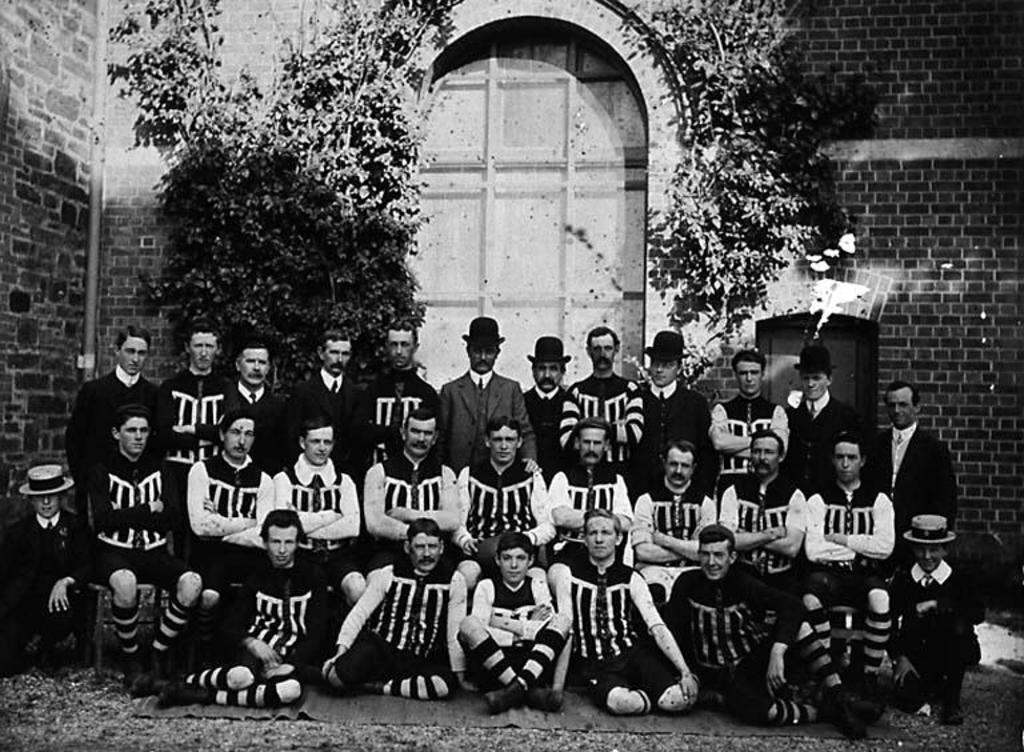What is the color scheme of the image? The image is black and white. Can you describe the people in the image? There are people in the image. What type of surface is visible in the image? There is ground visible in the image. What object is present in the image that people might sit or stand on? There is a mat in the image. What architectural feature can be seen in the image? There is a wall with an arch in the image. What type of entrance is present in the image? There is a door in the image. What type of vegetation is visible in the image? There are plants in the image. Can you tell me how many rivers are flowing through the image? There are no rivers visible in the image. What type of servant is attending to the people in the image? There are no servants present in the image. 